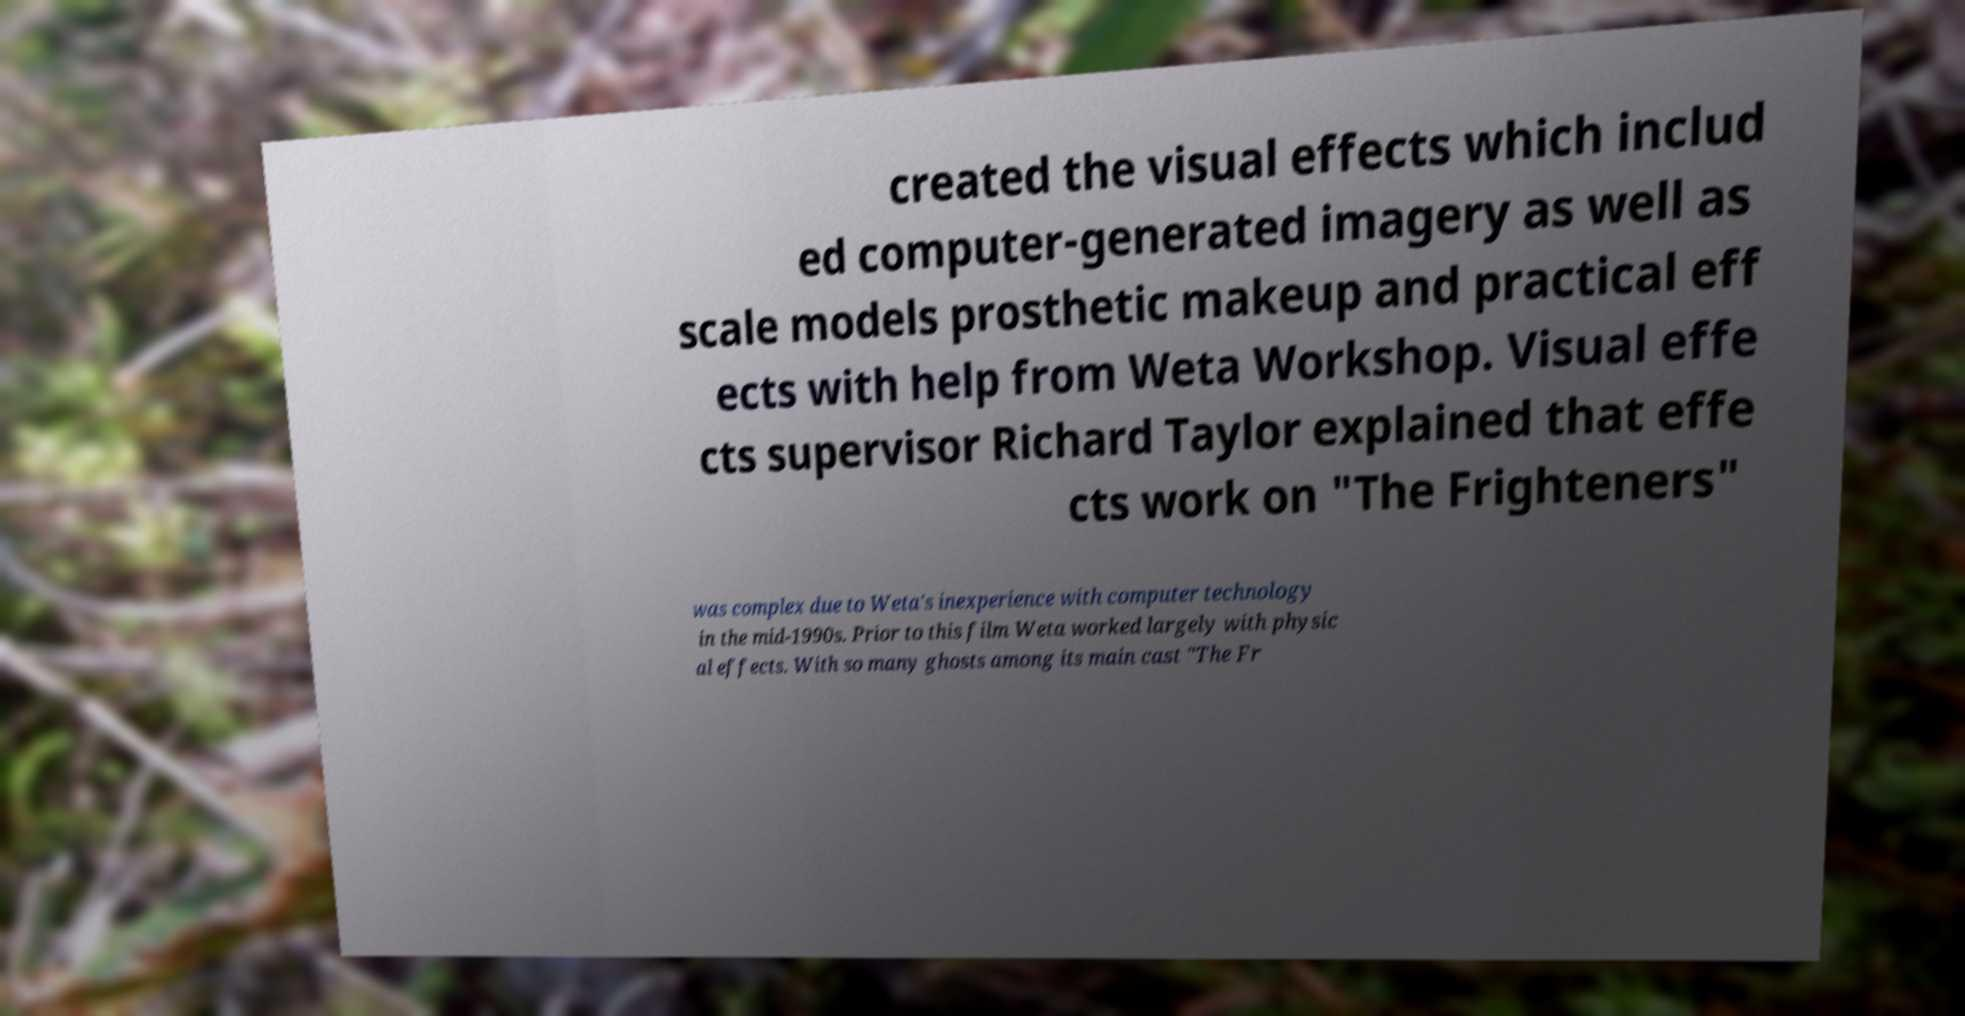Could you extract and type out the text from this image? created the visual effects which includ ed computer-generated imagery as well as scale models prosthetic makeup and practical eff ects with help from Weta Workshop. Visual effe cts supervisor Richard Taylor explained that effe cts work on "The Frighteners" was complex due to Weta's inexperience with computer technology in the mid-1990s. Prior to this film Weta worked largely with physic al effects. With so many ghosts among its main cast "The Fr 